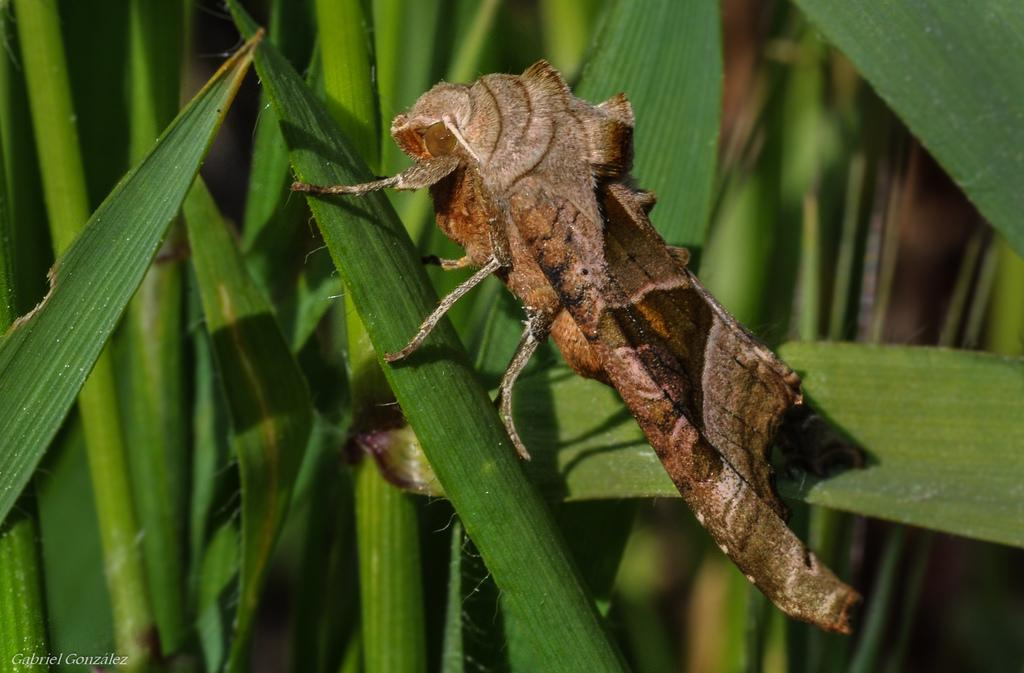What type of creature is in the picture? There is an insect in the picture. Can you identify the specific type of insect? The insect appears to be a silk moth. Where is the insect located in the image? The insect is on a leaf of a plant. What can be seen in the background of the image? There are plants or trees in the background of the image. How is the background of the image depicted? The background is blurred. How many oranges are hanging from the tree in the background of the image? There are no oranges present in the image; the background features plants or trees, but no specific fruit is mentioned. 